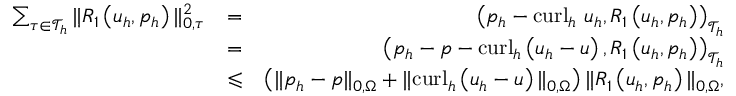<formula> <loc_0><loc_0><loc_500><loc_500>\begin{array} { r l r } { \sum _ { \tau \in \mathcal { T } _ { h } } \| R _ { 1 } \left ( u _ { h } , p _ { h } \right ) \| _ { 0 , \tau } ^ { 2 } } & { = } & { \left ( p _ { h } - c u r l _ { h } u _ { h } , R _ { 1 } \left ( u _ { h } , p _ { h } \right ) \right ) _ { \mathcal { T } _ { h } } } \\ & { = } & { \left ( p _ { h } - p - c u r l _ { h } \left ( u _ { h } - u \right ) , R _ { 1 } \left ( u _ { h } , p _ { h } \right ) \right ) _ { \mathcal { T } _ { h } } } \\ & { \leqslant } & { \left ( \| p _ { h } - p \| _ { 0 , \Omega } + \| c u r l _ { h } \left ( u _ { h } - u \right ) \| _ { 0 , \Omega } \right ) \| R _ { 1 } \left ( u _ { h } , p _ { h } \right ) \| _ { 0 , \Omega } , } \end{array}</formula> 